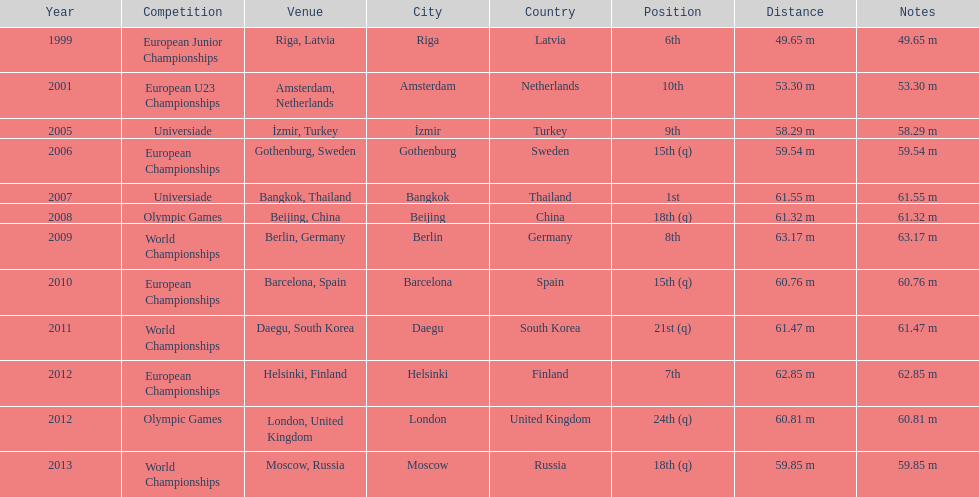Which year held the most competitions? 2012. 